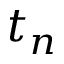<formula> <loc_0><loc_0><loc_500><loc_500>t _ { n }</formula> 